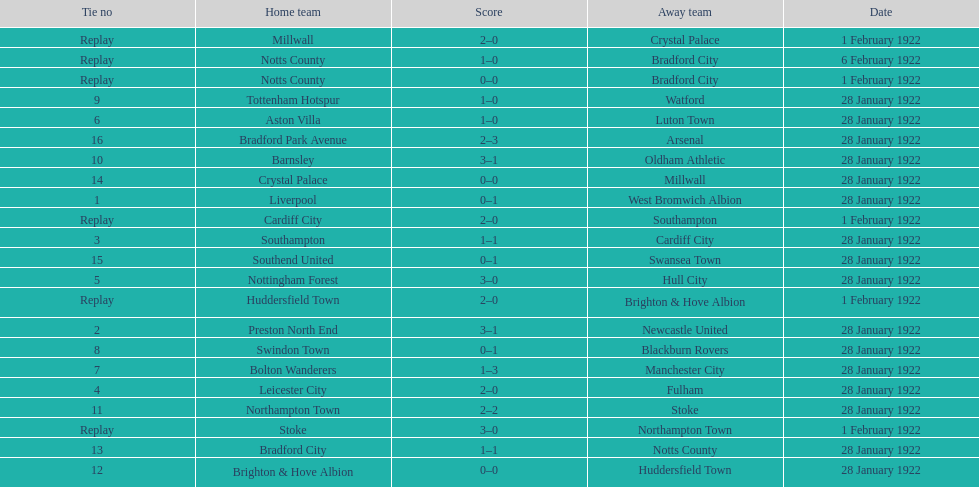Which game had a higher total number of goals scored, 1 or 16? 16. 